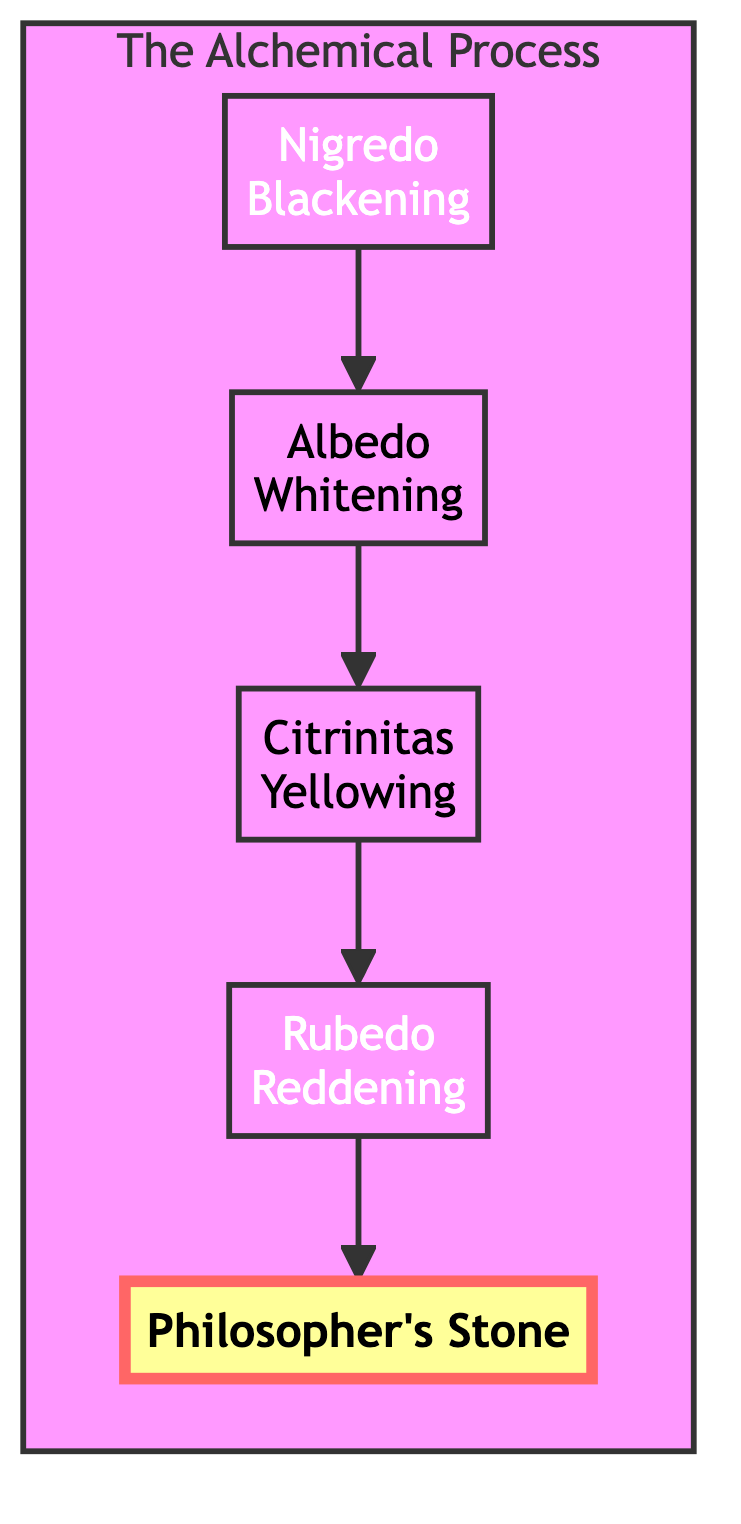What is the first stage of the alchemical process? The first stage indicated in the diagram is "Nigredo," which represents decay and decomposition, signifying the beginning of the transformation.
Answer: Nigredo Which symbol represents the Albedo stage? The Albedo stage is symbolized by the "white dove," as per the description next to the Albedo node in the diagram.
Answer: White dove How many total stages are in the alchemical process? The diagram shows five distinct stages (Nigredo, Albedo, Citrinitas, Rubedo, and the Philosopher's Stone), which we can count to determine the total.
Answer: Five What stage comes directly before the Rubedo stage? According to the flow of the diagram, "Citrinitas" is positioned directly before "Rubedo," indicating its sequential nature in the alchemical process.
Answer: Citrinitas What does the Philosopher's Stone symbolize? The description of the Philosopher's Stone in the diagram states that it symbolizes the culmination of the alchemical process and spiritual enlightenment.
Answer: Spiritual enlightenment Which stage is represented with a red substance? The diagram indicates that "Rubedo" is marked by the appearance of a red substance, highlighting its significance in the transformation process.
Answer: Rubedo What is the primary color associated with Nigredo? The diagram visually represents Nigredo with a black background, indicating its association with the color black.
Answer: Black Which stage signifies the dawning of solar light? Referring to the flow from the diagram, the stage "Citrinitas" is mentioned as the dawning of solar light, making it the correct answer.
Answer: Citrinitas Which two stages are linked by a direct arrow? The flow chart shows direct arrows connecting successive stages. The stages "Nigredo" and "Albedo" are one such pair that are directly connected by an arrow.
Answer: Nigredo and Albedo 